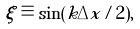<formula> <loc_0><loc_0><loc_500><loc_500>\xi \equiv \sin ( k \Delta x / 2 ) ,</formula> 